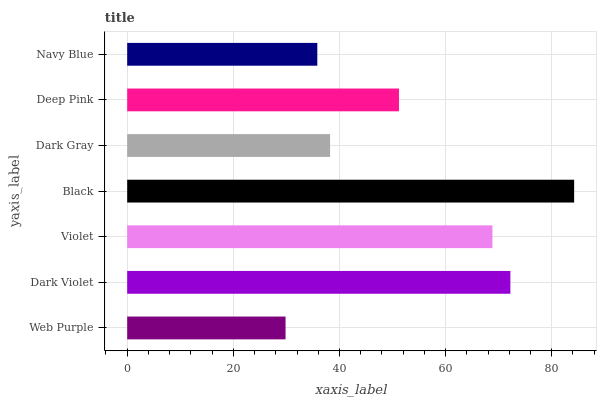Is Web Purple the minimum?
Answer yes or no. Yes. Is Black the maximum?
Answer yes or no. Yes. Is Dark Violet the minimum?
Answer yes or no. No. Is Dark Violet the maximum?
Answer yes or no. No. Is Dark Violet greater than Web Purple?
Answer yes or no. Yes. Is Web Purple less than Dark Violet?
Answer yes or no. Yes. Is Web Purple greater than Dark Violet?
Answer yes or no. No. Is Dark Violet less than Web Purple?
Answer yes or no. No. Is Deep Pink the high median?
Answer yes or no. Yes. Is Deep Pink the low median?
Answer yes or no. Yes. Is Black the high median?
Answer yes or no. No. Is Dark Gray the low median?
Answer yes or no. No. 